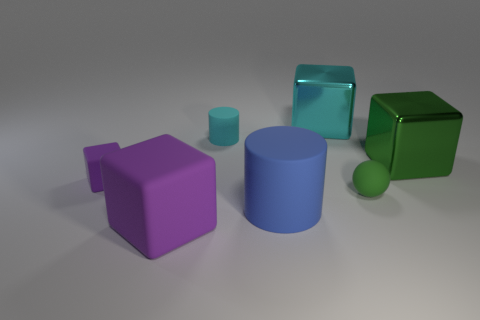Subtract all big green shiny blocks. How many blocks are left? 3 Subtract all spheres. How many objects are left? 6 Subtract 1 balls. How many balls are left? 0 Subtract all green cylinders. Subtract all cyan blocks. How many cylinders are left? 2 Subtract all green balls. How many yellow cylinders are left? 0 Subtract all large cylinders. Subtract all tiny spheres. How many objects are left? 5 Add 6 tiny cyan matte things. How many tiny cyan matte things are left? 7 Add 2 blue rubber cylinders. How many blue rubber cylinders exist? 3 Add 1 tiny blue things. How many objects exist? 8 Subtract all green blocks. How many blocks are left? 3 